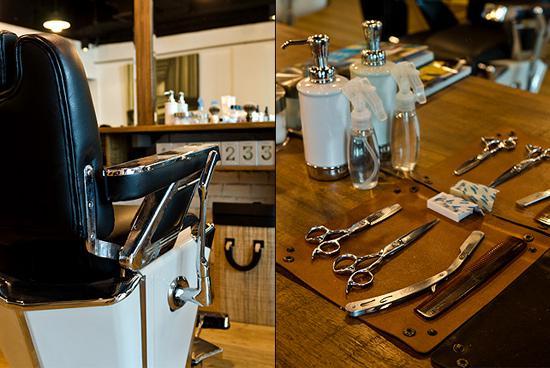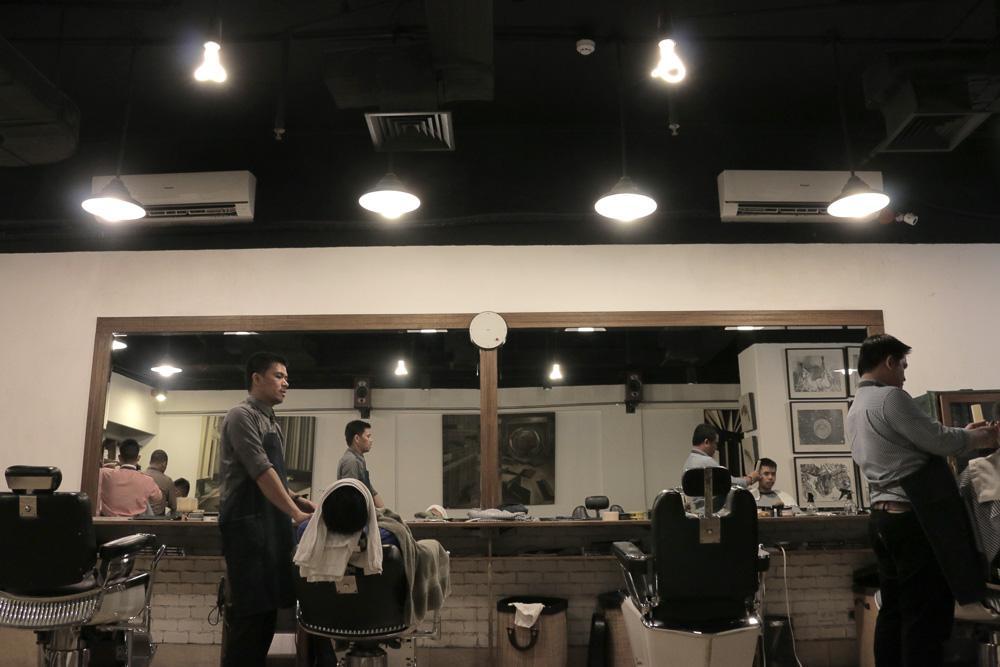The first image is the image on the left, the second image is the image on the right. For the images displayed, is the sentence "There is at least five people's reflections in the mirror." factually correct? Answer yes or no. Yes. The first image is the image on the left, the second image is the image on the right. Evaluate the accuracy of this statement regarding the images: "There is only one barber chair in the left image.". Is it true? Answer yes or no. Yes. 